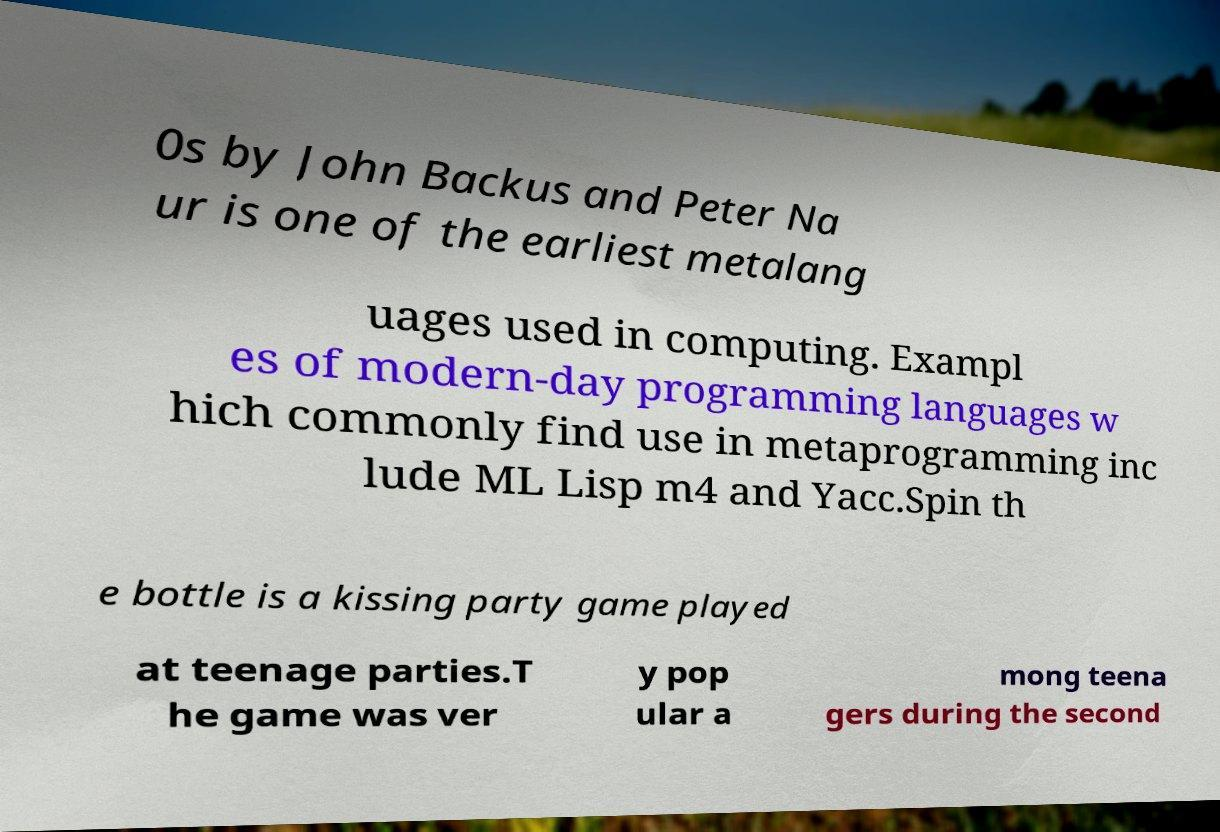Please identify and transcribe the text found in this image. 0s by John Backus and Peter Na ur is one of the earliest metalang uages used in computing. Exampl es of modern-day programming languages w hich commonly find use in metaprogramming inc lude ML Lisp m4 and Yacc.Spin th e bottle is a kissing party game played at teenage parties.T he game was ver y pop ular a mong teena gers during the second 